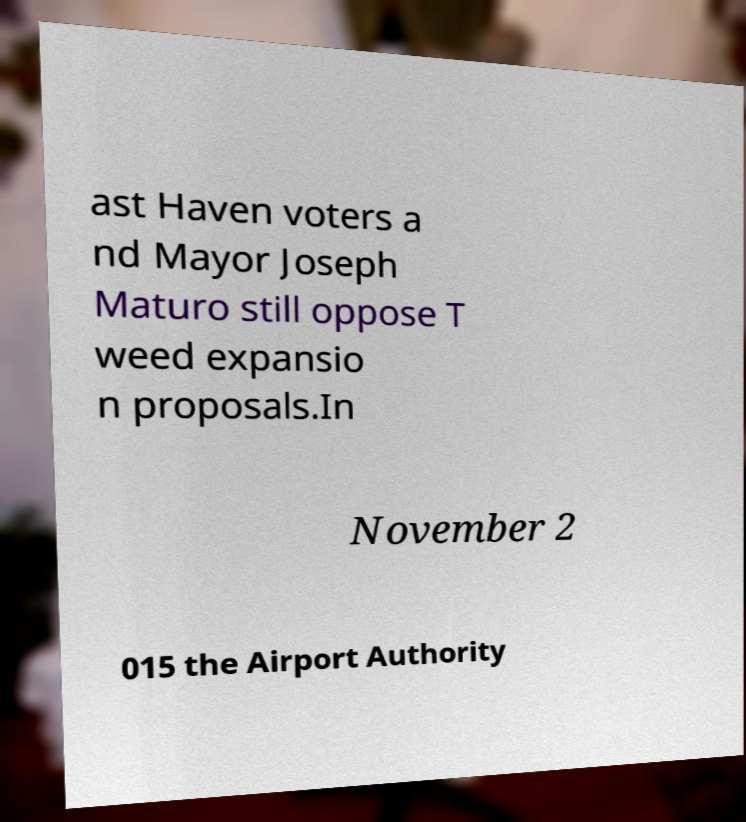Could you assist in decoding the text presented in this image and type it out clearly? ast Haven voters a nd Mayor Joseph Maturo still oppose T weed expansio n proposals.In November 2 015 the Airport Authority 